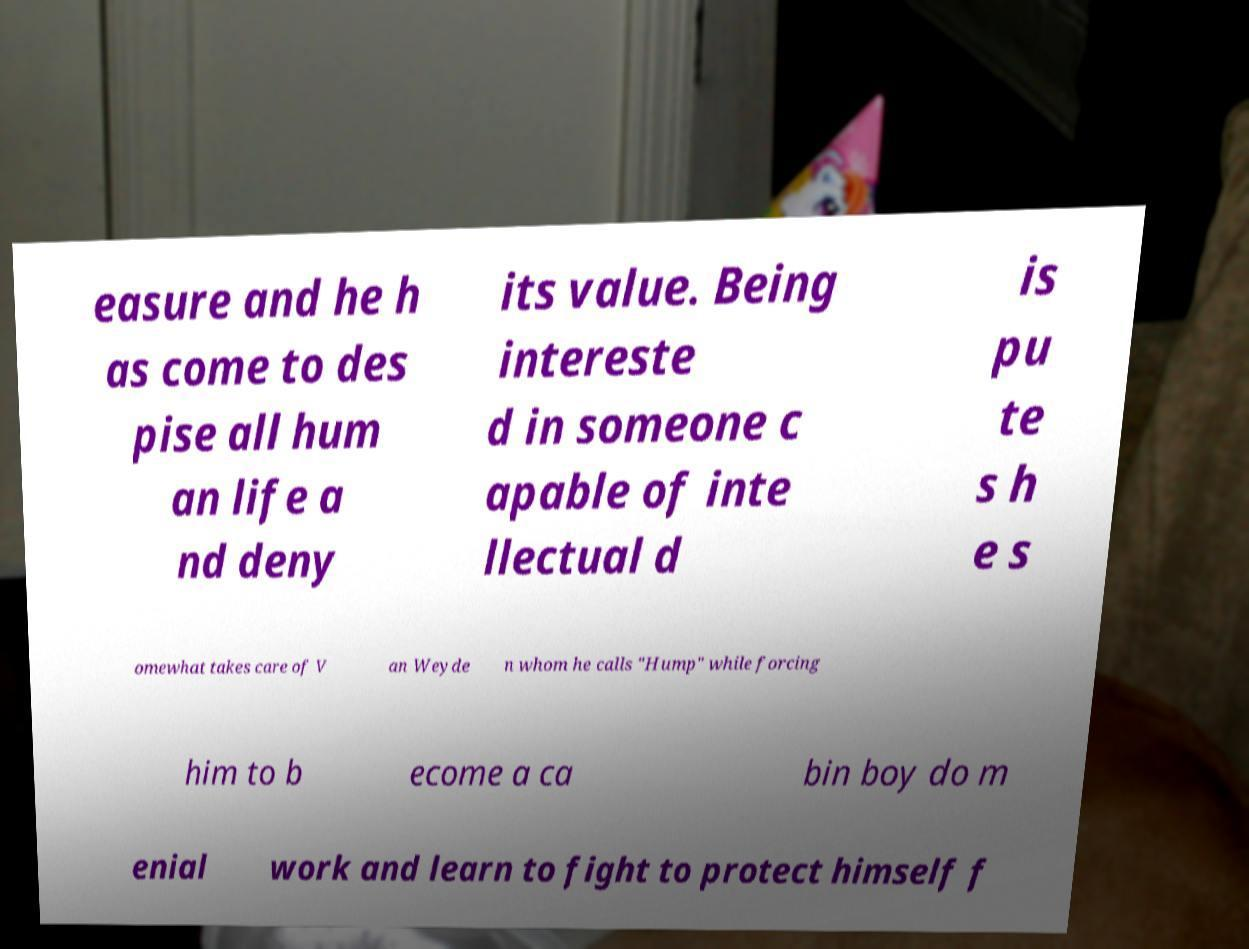Can you accurately transcribe the text from the provided image for me? easure and he h as come to des pise all hum an life a nd deny its value. Being intereste d in someone c apable of inte llectual d is pu te s h e s omewhat takes care of V an Weyde n whom he calls "Hump" while forcing him to b ecome a ca bin boy do m enial work and learn to fight to protect himself f 